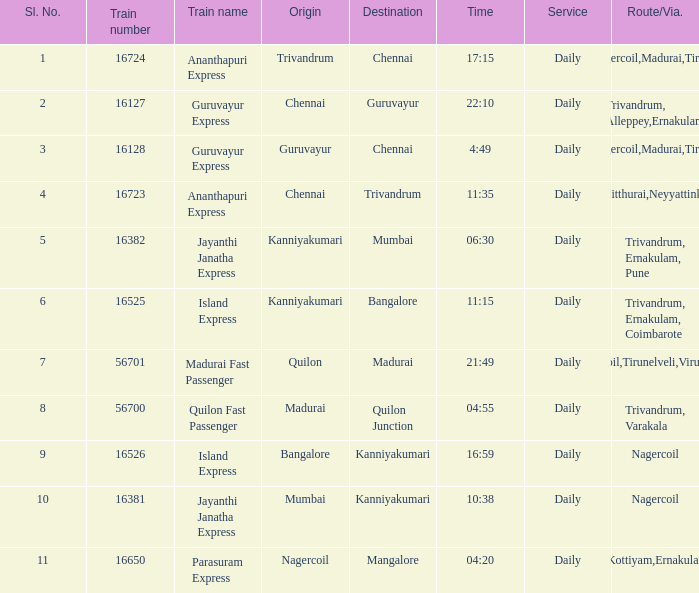When mumbai is the destination, what is the source location? Kanniyakumari. 